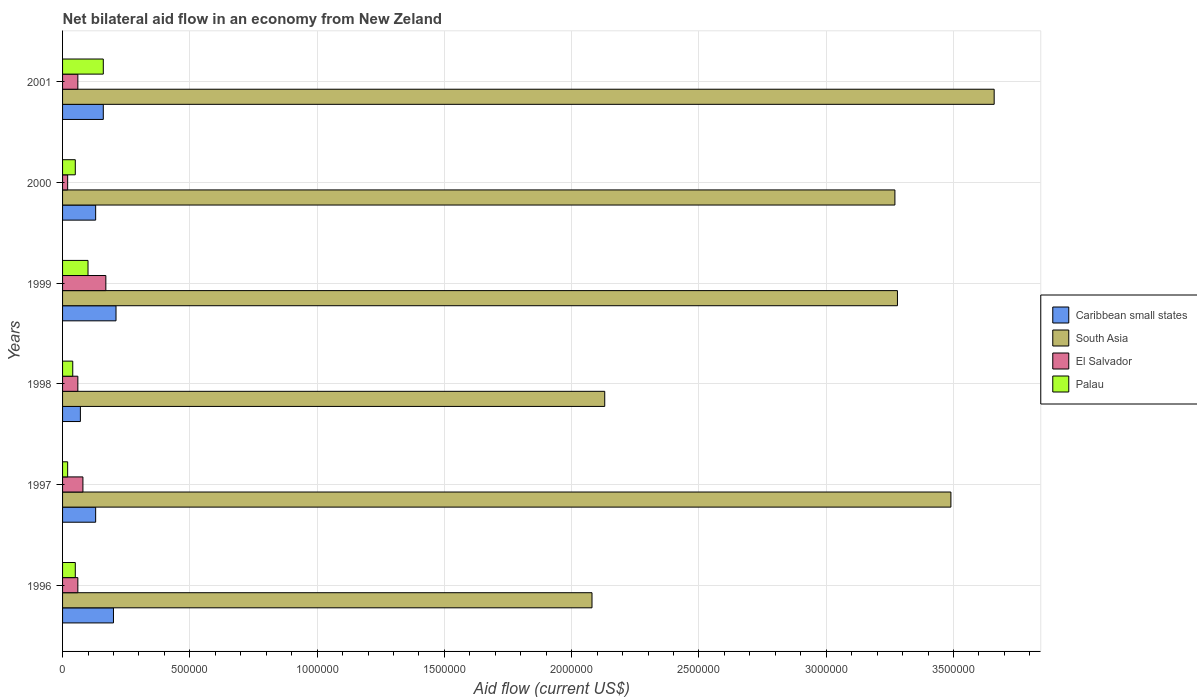How many groups of bars are there?
Give a very brief answer. 6. Are the number of bars on each tick of the Y-axis equal?
Your answer should be compact. Yes. What is the net bilateral aid flow in South Asia in 1999?
Your response must be concise. 3.28e+06. Across all years, what is the minimum net bilateral aid flow in El Salvador?
Provide a succinct answer. 2.00e+04. What is the difference between the net bilateral aid flow in South Asia in 1996 and that in 1997?
Offer a very short reply. -1.41e+06. What is the difference between the net bilateral aid flow in El Salvador in 2000 and the net bilateral aid flow in Palau in 1997?
Keep it short and to the point. 0. What is the average net bilateral aid flow in Palau per year?
Make the answer very short. 7.00e+04. Is the net bilateral aid flow in Caribbean small states in 1998 less than that in 1999?
Keep it short and to the point. Yes. What is the difference between the highest and the second highest net bilateral aid flow in Caribbean small states?
Your answer should be very brief. 10000. What is the difference between the highest and the lowest net bilateral aid flow in El Salvador?
Provide a short and direct response. 1.50e+05. In how many years, is the net bilateral aid flow in South Asia greater than the average net bilateral aid flow in South Asia taken over all years?
Give a very brief answer. 4. What does the 4th bar from the top in 1997 represents?
Make the answer very short. Caribbean small states. What does the 4th bar from the bottom in 1998 represents?
Your response must be concise. Palau. Is it the case that in every year, the sum of the net bilateral aid flow in Palau and net bilateral aid flow in El Salvador is greater than the net bilateral aid flow in Caribbean small states?
Your answer should be compact. No. How many bars are there?
Offer a very short reply. 24. Are all the bars in the graph horizontal?
Give a very brief answer. Yes. How many years are there in the graph?
Provide a short and direct response. 6. Where does the legend appear in the graph?
Make the answer very short. Center right. How are the legend labels stacked?
Ensure brevity in your answer.  Vertical. What is the title of the graph?
Offer a very short reply. Net bilateral aid flow in an economy from New Zeland. Does "Spain" appear as one of the legend labels in the graph?
Your response must be concise. No. What is the label or title of the X-axis?
Offer a very short reply. Aid flow (current US$). What is the Aid flow (current US$) of Caribbean small states in 1996?
Keep it short and to the point. 2.00e+05. What is the Aid flow (current US$) of South Asia in 1996?
Your answer should be compact. 2.08e+06. What is the Aid flow (current US$) in El Salvador in 1996?
Ensure brevity in your answer.  6.00e+04. What is the Aid flow (current US$) in Palau in 1996?
Ensure brevity in your answer.  5.00e+04. What is the Aid flow (current US$) of South Asia in 1997?
Your response must be concise. 3.49e+06. What is the Aid flow (current US$) of El Salvador in 1997?
Ensure brevity in your answer.  8.00e+04. What is the Aid flow (current US$) of Caribbean small states in 1998?
Your answer should be compact. 7.00e+04. What is the Aid flow (current US$) in South Asia in 1998?
Your answer should be very brief. 2.13e+06. What is the Aid flow (current US$) of Palau in 1998?
Give a very brief answer. 4.00e+04. What is the Aid flow (current US$) in Caribbean small states in 1999?
Offer a very short reply. 2.10e+05. What is the Aid flow (current US$) of South Asia in 1999?
Ensure brevity in your answer.  3.28e+06. What is the Aid flow (current US$) in South Asia in 2000?
Give a very brief answer. 3.27e+06. What is the Aid flow (current US$) in El Salvador in 2000?
Your response must be concise. 2.00e+04. What is the Aid flow (current US$) of South Asia in 2001?
Your answer should be compact. 3.66e+06. What is the Aid flow (current US$) in Palau in 2001?
Make the answer very short. 1.60e+05. Across all years, what is the maximum Aid flow (current US$) of Caribbean small states?
Your response must be concise. 2.10e+05. Across all years, what is the maximum Aid flow (current US$) of South Asia?
Provide a short and direct response. 3.66e+06. Across all years, what is the maximum Aid flow (current US$) of Palau?
Provide a succinct answer. 1.60e+05. Across all years, what is the minimum Aid flow (current US$) of Caribbean small states?
Offer a terse response. 7.00e+04. Across all years, what is the minimum Aid flow (current US$) of South Asia?
Ensure brevity in your answer.  2.08e+06. Across all years, what is the minimum Aid flow (current US$) of Palau?
Provide a short and direct response. 2.00e+04. What is the total Aid flow (current US$) in Caribbean small states in the graph?
Offer a terse response. 9.00e+05. What is the total Aid flow (current US$) in South Asia in the graph?
Your answer should be compact. 1.79e+07. What is the total Aid flow (current US$) in El Salvador in the graph?
Ensure brevity in your answer.  4.50e+05. What is the total Aid flow (current US$) in Palau in the graph?
Offer a very short reply. 4.20e+05. What is the difference between the Aid flow (current US$) of South Asia in 1996 and that in 1997?
Ensure brevity in your answer.  -1.41e+06. What is the difference between the Aid flow (current US$) of El Salvador in 1996 and that in 1997?
Your answer should be very brief. -2.00e+04. What is the difference between the Aid flow (current US$) in Caribbean small states in 1996 and that in 1998?
Your answer should be very brief. 1.30e+05. What is the difference between the Aid flow (current US$) in South Asia in 1996 and that in 1999?
Your answer should be compact. -1.20e+06. What is the difference between the Aid flow (current US$) in Palau in 1996 and that in 1999?
Ensure brevity in your answer.  -5.00e+04. What is the difference between the Aid flow (current US$) in Caribbean small states in 1996 and that in 2000?
Provide a short and direct response. 7.00e+04. What is the difference between the Aid flow (current US$) in South Asia in 1996 and that in 2000?
Offer a terse response. -1.19e+06. What is the difference between the Aid flow (current US$) in Palau in 1996 and that in 2000?
Provide a short and direct response. 0. What is the difference between the Aid flow (current US$) in Caribbean small states in 1996 and that in 2001?
Offer a terse response. 4.00e+04. What is the difference between the Aid flow (current US$) of South Asia in 1996 and that in 2001?
Offer a very short reply. -1.58e+06. What is the difference between the Aid flow (current US$) in El Salvador in 1996 and that in 2001?
Ensure brevity in your answer.  0. What is the difference between the Aid flow (current US$) in South Asia in 1997 and that in 1998?
Ensure brevity in your answer.  1.36e+06. What is the difference between the Aid flow (current US$) in El Salvador in 1997 and that in 1998?
Your answer should be very brief. 2.00e+04. What is the difference between the Aid flow (current US$) of Caribbean small states in 1997 and that in 2000?
Your answer should be very brief. 0. What is the difference between the Aid flow (current US$) of El Salvador in 1997 and that in 2000?
Provide a succinct answer. 6.00e+04. What is the difference between the Aid flow (current US$) in South Asia in 1997 and that in 2001?
Provide a succinct answer. -1.70e+05. What is the difference between the Aid flow (current US$) in Palau in 1997 and that in 2001?
Your response must be concise. -1.40e+05. What is the difference between the Aid flow (current US$) of Caribbean small states in 1998 and that in 1999?
Your answer should be very brief. -1.40e+05. What is the difference between the Aid flow (current US$) in South Asia in 1998 and that in 1999?
Offer a terse response. -1.15e+06. What is the difference between the Aid flow (current US$) in Palau in 1998 and that in 1999?
Give a very brief answer. -6.00e+04. What is the difference between the Aid flow (current US$) in South Asia in 1998 and that in 2000?
Offer a terse response. -1.14e+06. What is the difference between the Aid flow (current US$) in El Salvador in 1998 and that in 2000?
Make the answer very short. 4.00e+04. What is the difference between the Aid flow (current US$) in Palau in 1998 and that in 2000?
Provide a short and direct response. -10000. What is the difference between the Aid flow (current US$) of Caribbean small states in 1998 and that in 2001?
Your answer should be very brief. -9.00e+04. What is the difference between the Aid flow (current US$) of South Asia in 1998 and that in 2001?
Your answer should be very brief. -1.53e+06. What is the difference between the Aid flow (current US$) of Palau in 1998 and that in 2001?
Provide a succinct answer. -1.20e+05. What is the difference between the Aid flow (current US$) in Caribbean small states in 1999 and that in 2000?
Your response must be concise. 8.00e+04. What is the difference between the Aid flow (current US$) of South Asia in 1999 and that in 2000?
Your answer should be compact. 10000. What is the difference between the Aid flow (current US$) in Palau in 1999 and that in 2000?
Keep it short and to the point. 5.00e+04. What is the difference between the Aid flow (current US$) of Caribbean small states in 1999 and that in 2001?
Your answer should be very brief. 5.00e+04. What is the difference between the Aid flow (current US$) of South Asia in 1999 and that in 2001?
Ensure brevity in your answer.  -3.80e+05. What is the difference between the Aid flow (current US$) of El Salvador in 1999 and that in 2001?
Give a very brief answer. 1.10e+05. What is the difference between the Aid flow (current US$) in Caribbean small states in 2000 and that in 2001?
Provide a succinct answer. -3.00e+04. What is the difference between the Aid flow (current US$) of South Asia in 2000 and that in 2001?
Your answer should be compact. -3.90e+05. What is the difference between the Aid flow (current US$) of Palau in 2000 and that in 2001?
Give a very brief answer. -1.10e+05. What is the difference between the Aid flow (current US$) of Caribbean small states in 1996 and the Aid flow (current US$) of South Asia in 1997?
Ensure brevity in your answer.  -3.29e+06. What is the difference between the Aid flow (current US$) of Caribbean small states in 1996 and the Aid flow (current US$) of El Salvador in 1997?
Your response must be concise. 1.20e+05. What is the difference between the Aid flow (current US$) in Caribbean small states in 1996 and the Aid flow (current US$) in Palau in 1997?
Ensure brevity in your answer.  1.80e+05. What is the difference between the Aid flow (current US$) of South Asia in 1996 and the Aid flow (current US$) of El Salvador in 1997?
Make the answer very short. 2.00e+06. What is the difference between the Aid flow (current US$) of South Asia in 1996 and the Aid flow (current US$) of Palau in 1997?
Provide a succinct answer. 2.06e+06. What is the difference between the Aid flow (current US$) of El Salvador in 1996 and the Aid flow (current US$) of Palau in 1997?
Provide a short and direct response. 4.00e+04. What is the difference between the Aid flow (current US$) in Caribbean small states in 1996 and the Aid flow (current US$) in South Asia in 1998?
Offer a terse response. -1.93e+06. What is the difference between the Aid flow (current US$) of Caribbean small states in 1996 and the Aid flow (current US$) of El Salvador in 1998?
Provide a succinct answer. 1.40e+05. What is the difference between the Aid flow (current US$) in Caribbean small states in 1996 and the Aid flow (current US$) in Palau in 1998?
Your answer should be compact. 1.60e+05. What is the difference between the Aid flow (current US$) in South Asia in 1996 and the Aid flow (current US$) in El Salvador in 1998?
Keep it short and to the point. 2.02e+06. What is the difference between the Aid flow (current US$) of South Asia in 1996 and the Aid flow (current US$) of Palau in 1998?
Your response must be concise. 2.04e+06. What is the difference between the Aid flow (current US$) of Caribbean small states in 1996 and the Aid flow (current US$) of South Asia in 1999?
Your response must be concise. -3.08e+06. What is the difference between the Aid flow (current US$) in Caribbean small states in 1996 and the Aid flow (current US$) in El Salvador in 1999?
Your response must be concise. 3.00e+04. What is the difference between the Aid flow (current US$) of Caribbean small states in 1996 and the Aid flow (current US$) of Palau in 1999?
Provide a succinct answer. 1.00e+05. What is the difference between the Aid flow (current US$) in South Asia in 1996 and the Aid flow (current US$) in El Salvador in 1999?
Offer a very short reply. 1.91e+06. What is the difference between the Aid flow (current US$) in South Asia in 1996 and the Aid flow (current US$) in Palau in 1999?
Ensure brevity in your answer.  1.98e+06. What is the difference between the Aid flow (current US$) in El Salvador in 1996 and the Aid flow (current US$) in Palau in 1999?
Provide a short and direct response. -4.00e+04. What is the difference between the Aid flow (current US$) of Caribbean small states in 1996 and the Aid flow (current US$) of South Asia in 2000?
Ensure brevity in your answer.  -3.07e+06. What is the difference between the Aid flow (current US$) in Caribbean small states in 1996 and the Aid flow (current US$) in Palau in 2000?
Your answer should be very brief. 1.50e+05. What is the difference between the Aid flow (current US$) in South Asia in 1996 and the Aid flow (current US$) in El Salvador in 2000?
Offer a very short reply. 2.06e+06. What is the difference between the Aid flow (current US$) in South Asia in 1996 and the Aid flow (current US$) in Palau in 2000?
Offer a terse response. 2.03e+06. What is the difference between the Aid flow (current US$) of El Salvador in 1996 and the Aid flow (current US$) of Palau in 2000?
Your answer should be compact. 10000. What is the difference between the Aid flow (current US$) in Caribbean small states in 1996 and the Aid flow (current US$) in South Asia in 2001?
Offer a very short reply. -3.46e+06. What is the difference between the Aid flow (current US$) of Caribbean small states in 1996 and the Aid flow (current US$) of El Salvador in 2001?
Your answer should be compact. 1.40e+05. What is the difference between the Aid flow (current US$) of Caribbean small states in 1996 and the Aid flow (current US$) of Palau in 2001?
Ensure brevity in your answer.  4.00e+04. What is the difference between the Aid flow (current US$) in South Asia in 1996 and the Aid flow (current US$) in El Salvador in 2001?
Offer a terse response. 2.02e+06. What is the difference between the Aid flow (current US$) in South Asia in 1996 and the Aid flow (current US$) in Palau in 2001?
Your answer should be compact. 1.92e+06. What is the difference between the Aid flow (current US$) of El Salvador in 1996 and the Aid flow (current US$) of Palau in 2001?
Keep it short and to the point. -1.00e+05. What is the difference between the Aid flow (current US$) of Caribbean small states in 1997 and the Aid flow (current US$) of South Asia in 1998?
Offer a very short reply. -2.00e+06. What is the difference between the Aid flow (current US$) of Caribbean small states in 1997 and the Aid flow (current US$) of El Salvador in 1998?
Provide a succinct answer. 7.00e+04. What is the difference between the Aid flow (current US$) in Caribbean small states in 1997 and the Aid flow (current US$) in Palau in 1998?
Provide a short and direct response. 9.00e+04. What is the difference between the Aid flow (current US$) in South Asia in 1997 and the Aid flow (current US$) in El Salvador in 1998?
Keep it short and to the point. 3.43e+06. What is the difference between the Aid flow (current US$) in South Asia in 1997 and the Aid flow (current US$) in Palau in 1998?
Your answer should be very brief. 3.45e+06. What is the difference between the Aid flow (current US$) of Caribbean small states in 1997 and the Aid flow (current US$) of South Asia in 1999?
Keep it short and to the point. -3.15e+06. What is the difference between the Aid flow (current US$) in South Asia in 1997 and the Aid flow (current US$) in El Salvador in 1999?
Offer a very short reply. 3.32e+06. What is the difference between the Aid flow (current US$) in South Asia in 1997 and the Aid flow (current US$) in Palau in 1999?
Provide a succinct answer. 3.39e+06. What is the difference between the Aid flow (current US$) in El Salvador in 1997 and the Aid flow (current US$) in Palau in 1999?
Provide a succinct answer. -2.00e+04. What is the difference between the Aid flow (current US$) of Caribbean small states in 1997 and the Aid flow (current US$) of South Asia in 2000?
Provide a short and direct response. -3.14e+06. What is the difference between the Aid flow (current US$) in South Asia in 1997 and the Aid flow (current US$) in El Salvador in 2000?
Your response must be concise. 3.47e+06. What is the difference between the Aid flow (current US$) of South Asia in 1997 and the Aid flow (current US$) of Palau in 2000?
Keep it short and to the point. 3.44e+06. What is the difference between the Aid flow (current US$) of El Salvador in 1997 and the Aid flow (current US$) of Palau in 2000?
Provide a short and direct response. 3.00e+04. What is the difference between the Aid flow (current US$) of Caribbean small states in 1997 and the Aid flow (current US$) of South Asia in 2001?
Provide a succinct answer. -3.53e+06. What is the difference between the Aid flow (current US$) in South Asia in 1997 and the Aid flow (current US$) in El Salvador in 2001?
Keep it short and to the point. 3.43e+06. What is the difference between the Aid flow (current US$) in South Asia in 1997 and the Aid flow (current US$) in Palau in 2001?
Your answer should be very brief. 3.33e+06. What is the difference between the Aid flow (current US$) in El Salvador in 1997 and the Aid flow (current US$) in Palau in 2001?
Give a very brief answer. -8.00e+04. What is the difference between the Aid flow (current US$) of Caribbean small states in 1998 and the Aid flow (current US$) of South Asia in 1999?
Offer a terse response. -3.21e+06. What is the difference between the Aid flow (current US$) in Caribbean small states in 1998 and the Aid flow (current US$) in Palau in 1999?
Your answer should be compact. -3.00e+04. What is the difference between the Aid flow (current US$) in South Asia in 1998 and the Aid flow (current US$) in El Salvador in 1999?
Provide a short and direct response. 1.96e+06. What is the difference between the Aid flow (current US$) in South Asia in 1998 and the Aid flow (current US$) in Palau in 1999?
Your answer should be compact. 2.03e+06. What is the difference between the Aid flow (current US$) of Caribbean small states in 1998 and the Aid flow (current US$) of South Asia in 2000?
Give a very brief answer. -3.20e+06. What is the difference between the Aid flow (current US$) of South Asia in 1998 and the Aid flow (current US$) of El Salvador in 2000?
Give a very brief answer. 2.11e+06. What is the difference between the Aid flow (current US$) in South Asia in 1998 and the Aid flow (current US$) in Palau in 2000?
Provide a short and direct response. 2.08e+06. What is the difference between the Aid flow (current US$) in El Salvador in 1998 and the Aid flow (current US$) in Palau in 2000?
Provide a short and direct response. 10000. What is the difference between the Aid flow (current US$) in Caribbean small states in 1998 and the Aid flow (current US$) in South Asia in 2001?
Keep it short and to the point. -3.59e+06. What is the difference between the Aid flow (current US$) in Caribbean small states in 1998 and the Aid flow (current US$) in Palau in 2001?
Your answer should be very brief. -9.00e+04. What is the difference between the Aid flow (current US$) in South Asia in 1998 and the Aid flow (current US$) in El Salvador in 2001?
Your answer should be very brief. 2.07e+06. What is the difference between the Aid flow (current US$) of South Asia in 1998 and the Aid flow (current US$) of Palau in 2001?
Your answer should be compact. 1.97e+06. What is the difference between the Aid flow (current US$) of El Salvador in 1998 and the Aid flow (current US$) of Palau in 2001?
Offer a terse response. -1.00e+05. What is the difference between the Aid flow (current US$) of Caribbean small states in 1999 and the Aid flow (current US$) of South Asia in 2000?
Make the answer very short. -3.06e+06. What is the difference between the Aid flow (current US$) of Caribbean small states in 1999 and the Aid flow (current US$) of Palau in 2000?
Keep it short and to the point. 1.60e+05. What is the difference between the Aid flow (current US$) in South Asia in 1999 and the Aid flow (current US$) in El Salvador in 2000?
Offer a terse response. 3.26e+06. What is the difference between the Aid flow (current US$) in South Asia in 1999 and the Aid flow (current US$) in Palau in 2000?
Ensure brevity in your answer.  3.23e+06. What is the difference between the Aid flow (current US$) in El Salvador in 1999 and the Aid flow (current US$) in Palau in 2000?
Make the answer very short. 1.20e+05. What is the difference between the Aid flow (current US$) of Caribbean small states in 1999 and the Aid flow (current US$) of South Asia in 2001?
Provide a short and direct response. -3.45e+06. What is the difference between the Aid flow (current US$) in South Asia in 1999 and the Aid flow (current US$) in El Salvador in 2001?
Offer a very short reply. 3.22e+06. What is the difference between the Aid flow (current US$) in South Asia in 1999 and the Aid flow (current US$) in Palau in 2001?
Provide a short and direct response. 3.12e+06. What is the difference between the Aid flow (current US$) in El Salvador in 1999 and the Aid flow (current US$) in Palau in 2001?
Your answer should be very brief. 10000. What is the difference between the Aid flow (current US$) in Caribbean small states in 2000 and the Aid flow (current US$) in South Asia in 2001?
Offer a terse response. -3.53e+06. What is the difference between the Aid flow (current US$) in Caribbean small states in 2000 and the Aid flow (current US$) in El Salvador in 2001?
Offer a very short reply. 7.00e+04. What is the difference between the Aid flow (current US$) of Caribbean small states in 2000 and the Aid flow (current US$) of Palau in 2001?
Your answer should be compact. -3.00e+04. What is the difference between the Aid flow (current US$) of South Asia in 2000 and the Aid flow (current US$) of El Salvador in 2001?
Provide a succinct answer. 3.21e+06. What is the difference between the Aid flow (current US$) in South Asia in 2000 and the Aid flow (current US$) in Palau in 2001?
Offer a very short reply. 3.11e+06. What is the difference between the Aid flow (current US$) of El Salvador in 2000 and the Aid flow (current US$) of Palau in 2001?
Keep it short and to the point. -1.40e+05. What is the average Aid flow (current US$) in South Asia per year?
Give a very brief answer. 2.98e+06. What is the average Aid flow (current US$) in El Salvador per year?
Give a very brief answer. 7.50e+04. In the year 1996, what is the difference between the Aid flow (current US$) of Caribbean small states and Aid flow (current US$) of South Asia?
Offer a very short reply. -1.88e+06. In the year 1996, what is the difference between the Aid flow (current US$) of Caribbean small states and Aid flow (current US$) of El Salvador?
Your response must be concise. 1.40e+05. In the year 1996, what is the difference between the Aid flow (current US$) in South Asia and Aid flow (current US$) in El Salvador?
Your response must be concise. 2.02e+06. In the year 1996, what is the difference between the Aid flow (current US$) of South Asia and Aid flow (current US$) of Palau?
Give a very brief answer. 2.03e+06. In the year 1997, what is the difference between the Aid flow (current US$) of Caribbean small states and Aid flow (current US$) of South Asia?
Offer a very short reply. -3.36e+06. In the year 1997, what is the difference between the Aid flow (current US$) in Caribbean small states and Aid flow (current US$) in El Salvador?
Your answer should be compact. 5.00e+04. In the year 1997, what is the difference between the Aid flow (current US$) of South Asia and Aid flow (current US$) of El Salvador?
Ensure brevity in your answer.  3.41e+06. In the year 1997, what is the difference between the Aid flow (current US$) of South Asia and Aid flow (current US$) of Palau?
Provide a short and direct response. 3.47e+06. In the year 1998, what is the difference between the Aid flow (current US$) in Caribbean small states and Aid flow (current US$) in South Asia?
Your answer should be very brief. -2.06e+06. In the year 1998, what is the difference between the Aid flow (current US$) in Caribbean small states and Aid flow (current US$) in El Salvador?
Provide a short and direct response. 10000. In the year 1998, what is the difference between the Aid flow (current US$) in Caribbean small states and Aid flow (current US$) in Palau?
Make the answer very short. 3.00e+04. In the year 1998, what is the difference between the Aid flow (current US$) of South Asia and Aid flow (current US$) of El Salvador?
Offer a terse response. 2.07e+06. In the year 1998, what is the difference between the Aid flow (current US$) in South Asia and Aid flow (current US$) in Palau?
Your response must be concise. 2.09e+06. In the year 1999, what is the difference between the Aid flow (current US$) of Caribbean small states and Aid flow (current US$) of South Asia?
Ensure brevity in your answer.  -3.07e+06. In the year 1999, what is the difference between the Aid flow (current US$) of Caribbean small states and Aid flow (current US$) of El Salvador?
Keep it short and to the point. 4.00e+04. In the year 1999, what is the difference between the Aid flow (current US$) in South Asia and Aid flow (current US$) in El Salvador?
Your answer should be compact. 3.11e+06. In the year 1999, what is the difference between the Aid flow (current US$) in South Asia and Aid flow (current US$) in Palau?
Make the answer very short. 3.18e+06. In the year 1999, what is the difference between the Aid flow (current US$) of El Salvador and Aid flow (current US$) of Palau?
Offer a very short reply. 7.00e+04. In the year 2000, what is the difference between the Aid flow (current US$) of Caribbean small states and Aid flow (current US$) of South Asia?
Your answer should be compact. -3.14e+06. In the year 2000, what is the difference between the Aid flow (current US$) in Caribbean small states and Aid flow (current US$) in Palau?
Your response must be concise. 8.00e+04. In the year 2000, what is the difference between the Aid flow (current US$) of South Asia and Aid flow (current US$) of El Salvador?
Provide a succinct answer. 3.25e+06. In the year 2000, what is the difference between the Aid flow (current US$) of South Asia and Aid flow (current US$) of Palau?
Your answer should be compact. 3.22e+06. In the year 2000, what is the difference between the Aid flow (current US$) in El Salvador and Aid flow (current US$) in Palau?
Make the answer very short. -3.00e+04. In the year 2001, what is the difference between the Aid flow (current US$) of Caribbean small states and Aid flow (current US$) of South Asia?
Provide a succinct answer. -3.50e+06. In the year 2001, what is the difference between the Aid flow (current US$) in South Asia and Aid flow (current US$) in El Salvador?
Provide a succinct answer. 3.60e+06. In the year 2001, what is the difference between the Aid flow (current US$) of South Asia and Aid flow (current US$) of Palau?
Provide a succinct answer. 3.50e+06. In the year 2001, what is the difference between the Aid flow (current US$) in El Salvador and Aid flow (current US$) in Palau?
Offer a very short reply. -1.00e+05. What is the ratio of the Aid flow (current US$) of Caribbean small states in 1996 to that in 1997?
Provide a short and direct response. 1.54. What is the ratio of the Aid flow (current US$) in South Asia in 1996 to that in 1997?
Give a very brief answer. 0.6. What is the ratio of the Aid flow (current US$) in El Salvador in 1996 to that in 1997?
Your response must be concise. 0.75. What is the ratio of the Aid flow (current US$) in Palau in 1996 to that in 1997?
Your answer should be very brief. 2.5. What is the ratio of the Aid flow (current US$) of Caribbean small states in 1996 to that in 1998?
Offer a terse response. 2.86. What is the ratio of the Aid flow (current US$) in South Asia in 1996 to that in 1998?
Ensure brevity in your answer.  0.98. What is the ratio of the Aid flow (current US$) in El Salvador in 1996 to that in 1998?
Your answer should be very brief. 1. What is the ratio of the Aid flow (current US$) in Palau in 1996 to that in 1998?
Your answer should be very brief. 1.25. What is the ratio of the Aid flow (current US$) of South Asia in 1996 to that in 1999?
Provide a succinct answer. 0.63. What is the ratio of the Aid flow (current US$) in El Salvador in 1996 to that in 1999?
Offer a terse response. 0.35. What is the ratio of the Aid flow (current US$) of Palau in 1996 to that in 1999?
Provide a succinct answer. 0.5. What is the ratio of the Aid flow (current US$) of Caribbean small states in 1996 to that in 2000?
Ensure brevity in your answer.  1.54. What is the ratio of the Aid flow (current US$) of South Asia in 1996 to that in 2000?
Your response must be concise. 0.64. What is the ratio of the Aid flow (current US$) of Palau in 1996 to that in 2000?
Offer a terse response. 1. What is the ratio of the Aid flow (current US$) of Caribbean small states in 1996 to that in 2001?
Your answer should be compact. 1.25. What is the ratio of the Aid flow (current US$) of South Asia in 1996 to that in 2001?
Keep it short and to the point. 0.57. What is the ratio of the Aid flow (current US$) of El Salvador in 1996 to that in 2001?
Give a very brief answer. 1. What is the ratio of the Aid flow (current US$) of Palau in 1996 to that in 2001?
Offer a terse response. 0.31. What is the ratio of the Aid flow (current US$) in Caribbean small states in 1997 to that in 1998?
Your answer should be compact. 1.86. What is the ratio of the Aid flow (current US$) in South Asia in 1997 to that in 1998?
Give a very brief answer. 1.64. What is the ratio of the Aid flow (current US$) in El Salvador in 1997 to that in 1998?
Provide a short and direct response. 1.33. What is the ratio of the Aid flow (current US$) in Caribbean small states in 1997 to that in 1999?
Keep it short and to the point. 0.62. What is the ratio of the Aid flow (current US$) of South Asia in 1997 to that in 1999?
Ensure brevity in your answer.  1.06. What is the ratio of the Aid flow (current US$) in El Salvador in 1997 to that in 1999?
Keep it short and to the point. 0.47. What is the ratio of the Aid flow (current US$) in South Asia in 1997 to that in 2000?
Offer a very short reply. 1.07. What is the ratio of the Aid flow (current US$) of Palau in 1997 to that in 2000?
Provide a short and direct response. 0.4. What is the ratio of the Aid flow (current US$) in Caribbean small states in 1997 to that in 2001?
Your answer should be very brief. 0.81. What is the ratio of the Aid flow (current US$) in South Asia in 1997 to that in 2001?
Your answer should be very brief. 0.95. What is the ratio of the Aid flow (current US$) in Caribbean small states in 1998 to that in 1999?
Your response must be concise. 0.33. What is the ratio of the Aid flow (current US$) in South Asia in 1998 to that in 1999?
Your response must be concise. 0.65. What is the ratio of the Aid flow (current US$) of El Salvador in 1998 to that in 1999?
Offer a very short reply. 0.35. What is the ratio of the Aid flow (current US$) of Palau in 1998 to that in 1999?
Offer a very short reply. 0.4. What is the ratio of the Aid flow (current US$) of Caribbean small states in 1998 to that in 2000?
Provide a succinct answer. 0.54. What is the ratio of the Aid flow (current US$) of South Asia in 1998 to that in 2000?
Your answer should be compact. 0.65. What is the ratio of the Aid flow (current US$) in Caribbean small states in 1998 to that in 2001?
Ensure brevity in your answer.  0.44. What is the ratio of the Aid flow (current US$) of South Asia in 1998 to that in 2001?
Your response must be concise. 0.58. What is the ratio of the Aid flow (current US$) of El Salvador in 1998 to that in 2001?
Give a very brief answer. 1. What is the ratio of the Aid flow (current US$) of Caribbean small states in 1999 to that in 2000?
Your response must be concise. 1.62. What is the ratio of the Aid flow (current US$) of Palau in 1999 to that in 2000?
Provide a succinct answer. 2. What is the ratio of the Aid flow (current US$) of Caribbean small states in 1999 to that in 2001?
Offer a terse response. 1.31. What is the ratio of the Aid flow (current US$) in South Asia in 1999 to that in 2001?
Make the answer very short. 0.9. What is the ratio of the Aid flow (current US$) of El Salvador in 1999 to that in 2001?
Provide a succinct answer. 2.83. What is the ratio of the Aid flow (current US$) of Palau in 1999 to that in 2001?
Ensure brevity in your answer.  0.62. What is the ratio of the Aid flow (current US$) in Caribbean small states in 2000 to that in 2001?
Make the answer very short. 0.81. What is the ratio of the Aid flow (current US$) of South Asia in 2000 to that in 2001?
Offer a terse response. 0.89. What is the ratio of the Aid flow (current US$) in El Salvador in 2000 to that in 2001?
Your answer should be very brief. 0.33. What is the ratio of the Aid flow (current US$) in Palau in 2000 to that in 2001?
Provide a succinct answer. 0.31. What is the difference between the highest and the second highest Aid flow (current US$) in Caribbean small states?
Provide a succinct answer. 10000. What is the difference between the highest and the second highest Aid flow (current US$) in South Asia?
Give a very brief answer. 1.70e+05. What is the difference between the highest and the lowest Aid flow (current US$) in Caribbean small states?
Your response must be concise. 1.40e+05. What is the difference between the highest and the lowest Aid flow (current US$) in South Asia?
Keep it short and to the point. 1.58e+06. What is the difference between the highest and the lowest Aid flow (current US$) of El Salvador?
Make the answer very short. 1.50e+05. What is the difference between the highest and the lowest Aid flow (current US$) of Palau?
Offer a very short reply. 1.40e+05. 